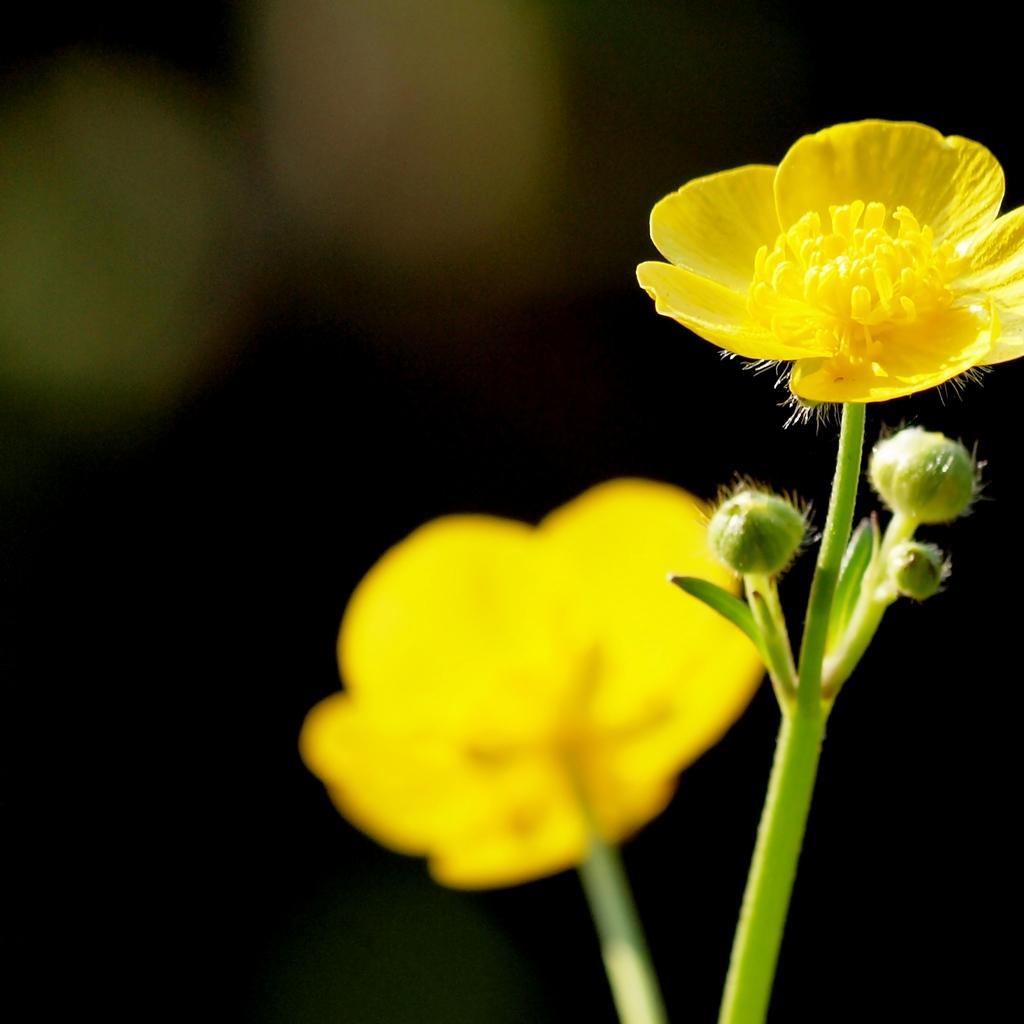Describe this image in one or two sentences. Here in this picture we can see a couple of yellow colored flowers present over there. 